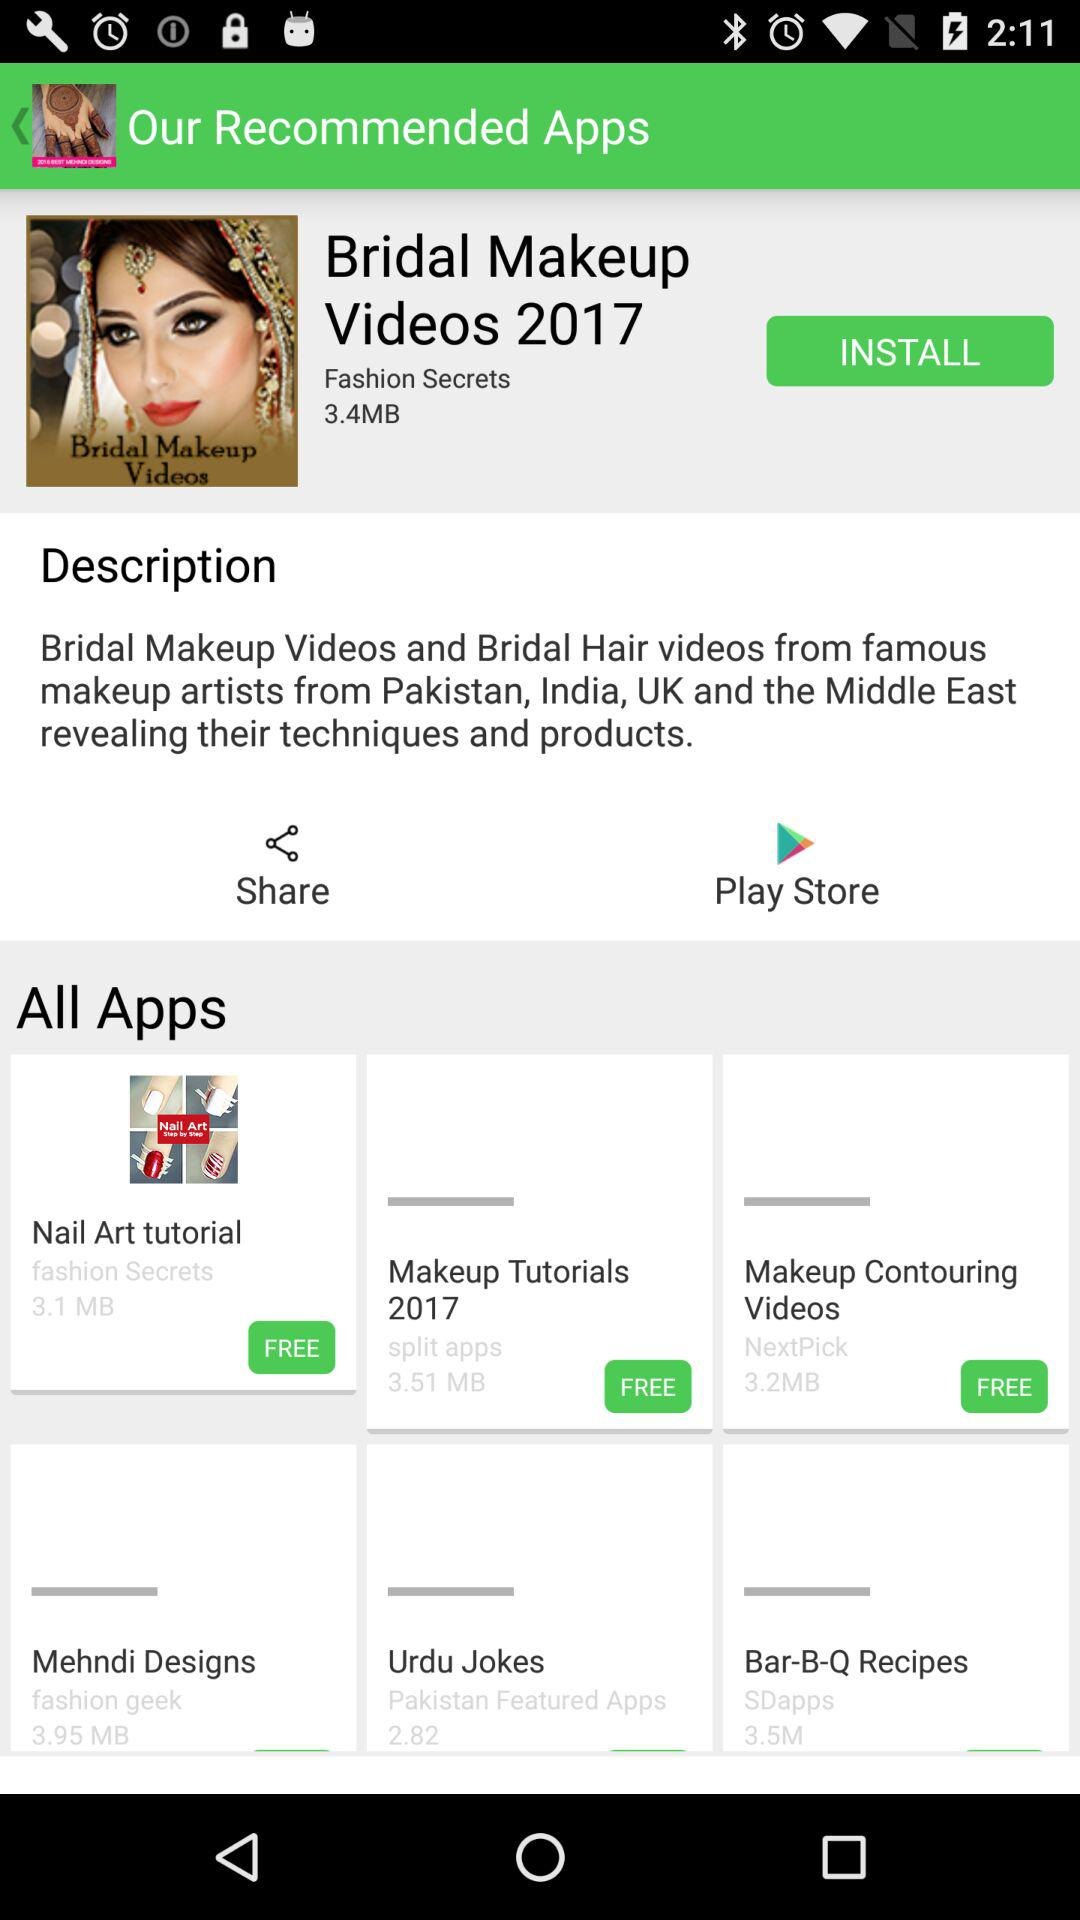What is the size of the "Bridal Makeup Videos 2017"? The size is 3.4MB. 